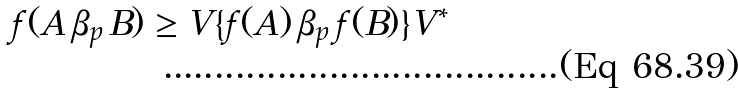<formula> <loc_0><loc_0><loc_500><loc_500>f ( A \, \beta _ { p } \, B ) \geq V \{ f ( A ) \, \beta _ { p } \, f ( B ) \} V ^ { * }</formula> 